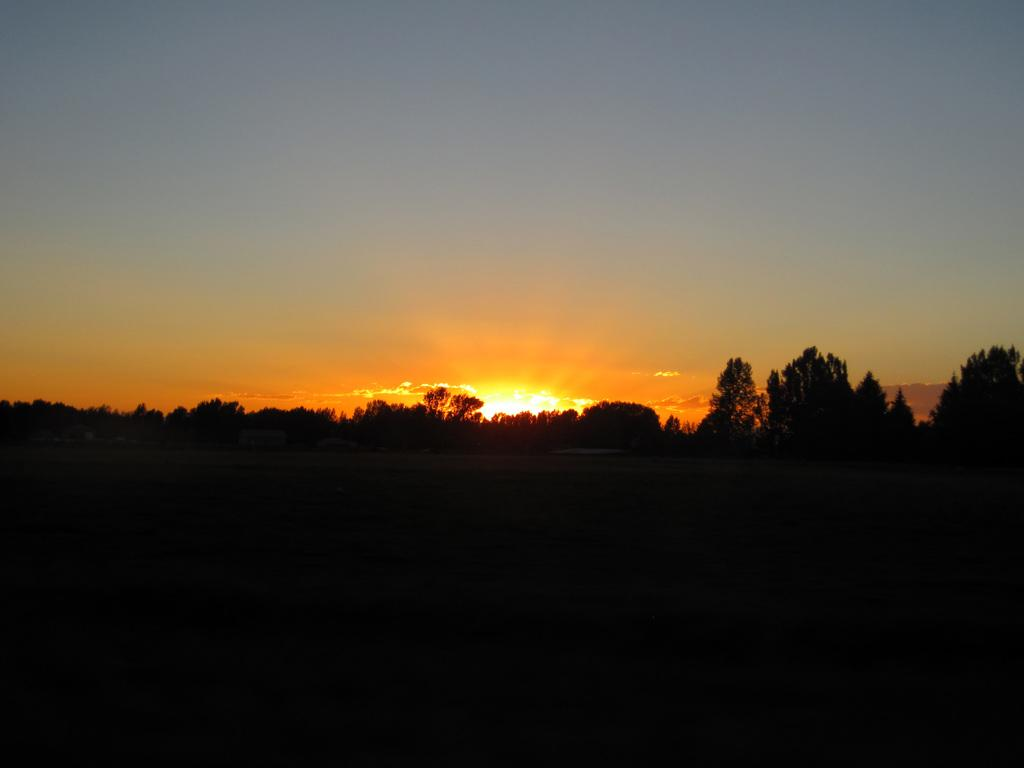What type of vegetation can be seen in the image? There are trees in the image. What part of the natural environment is visible in the image? The sky is visible in the image. What is the color or lighting condition of the bottom part of the image? The bottom part of the image is dark. What type of net is being used to catch the chess pieces in the image? There is no net or chess pieces present in the image; it features trees and a sky. What type of engine is powering the vehicle in the image? There is no vehicle or engine present in the image. 